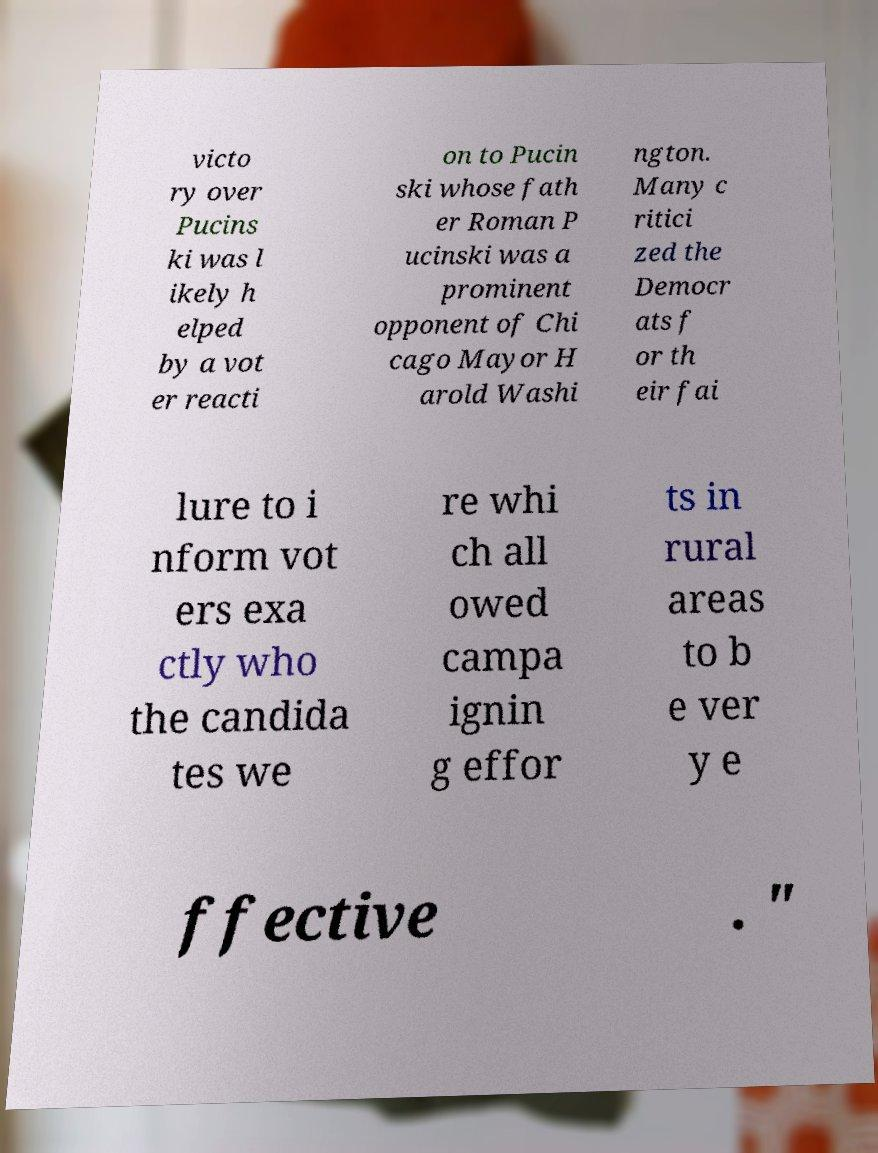There's text embedded in this image that I need extracted. Can you transcribe it verbatim? victo ry over Pucins ki was l ikely h elped by a vot er reacti on to Pucin ski whose fath er Roman P ucinski was a prominent opponent of Chi cago Mayor H arold Washi ngton. Many c ritici zed the Democr ats f or th eir fai lure to i nform vot ers exa ctly who the candida tes we re whi ch all owed campa ignin g effor ts in rural areas to b e ver y e ffective . " 